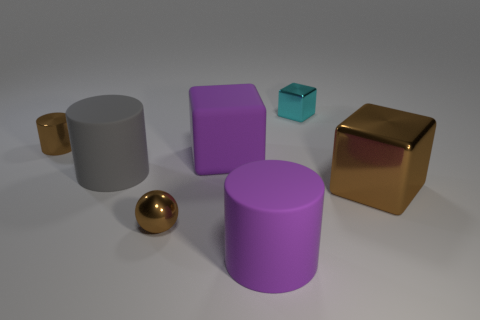Subtract all metallic cylinders. How many cylinders are left? 2 Add 1 large gray rubber balls. How many objects exist? 8 Subtract 2 cylinders. How many cylinders are left? 1 Subtract all purple spheres. How many purple cylinders are left? 1 Subtract all cylinders. How many objects are left? 4 Subtract all purple cylinders. Subtract all brown blocks. How many cylinders are left? 2 Add 4 tiny shiny cylinders. How many tiny shiny cylinders are left? 5 Add 2 big cyan matte cubes. How many big cyan matte cubes exist? 2 Subtract 1 purple cubes. How many objects are left? 6 Subtract all green blocks. Subtract all cubes. How many objects are left? 4 